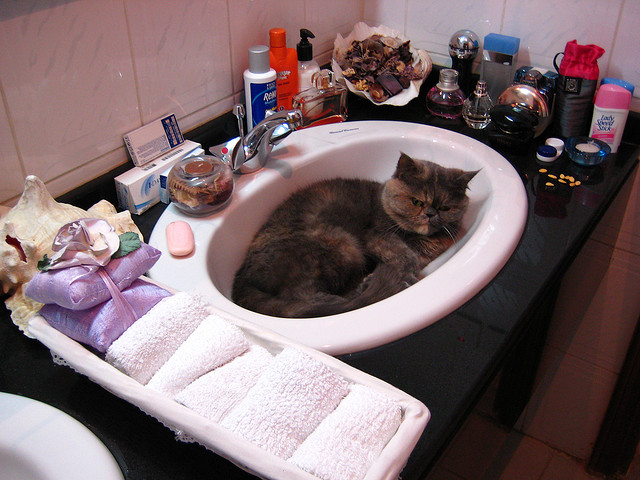Does the cat look happy?
Answer the question using a single word or phrase. No Should the cat be here? No Do you see deodorant on the sink top? Yes 